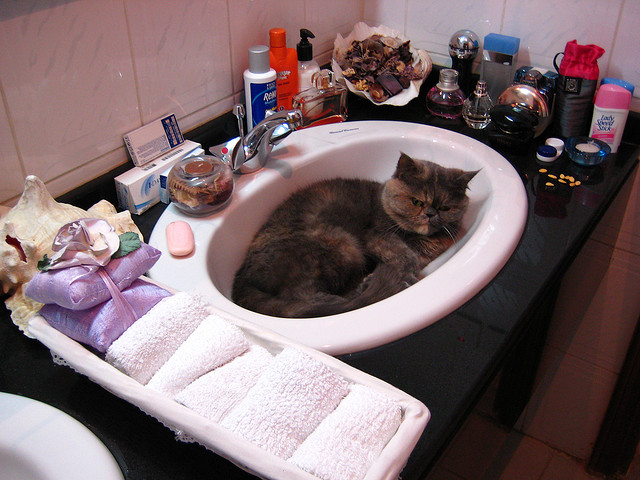Does the cat look happy?
Answer the question using a single word or phrase. No Should the cat be here? No Do you see deodorant on the sink top? Yes 